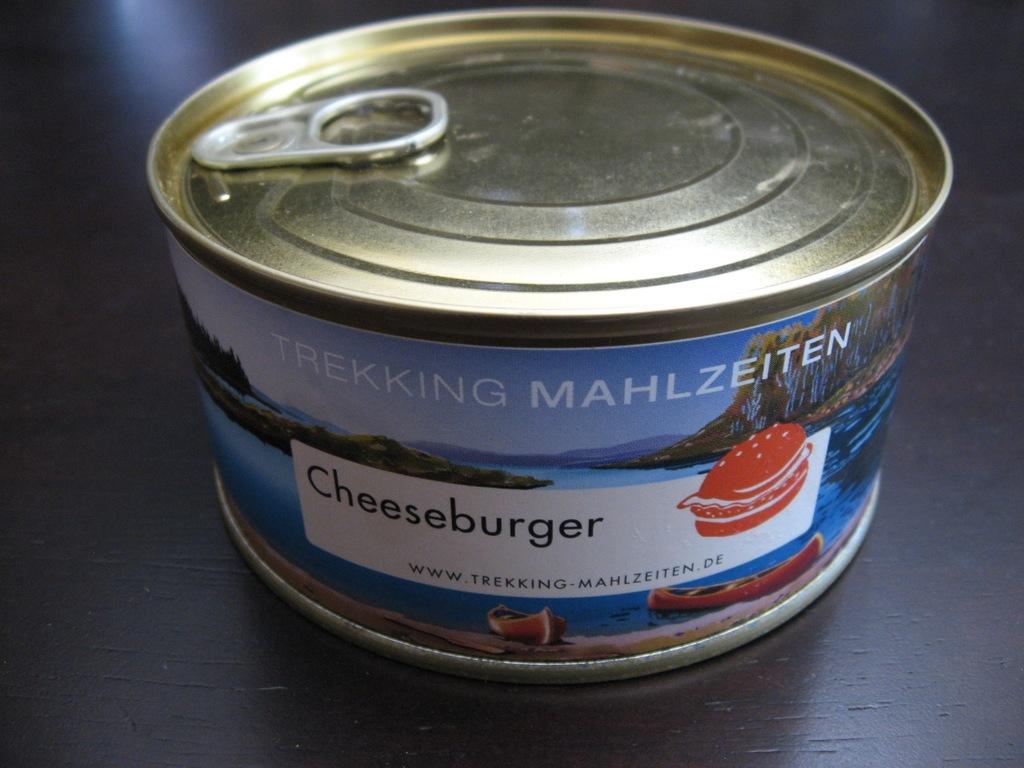What flavor does the label say the food is in the can?
Provide a short and direct response. Cheeseburger. What brand is this?
Provide a short and direct response. Trekking mahlzeiten. 